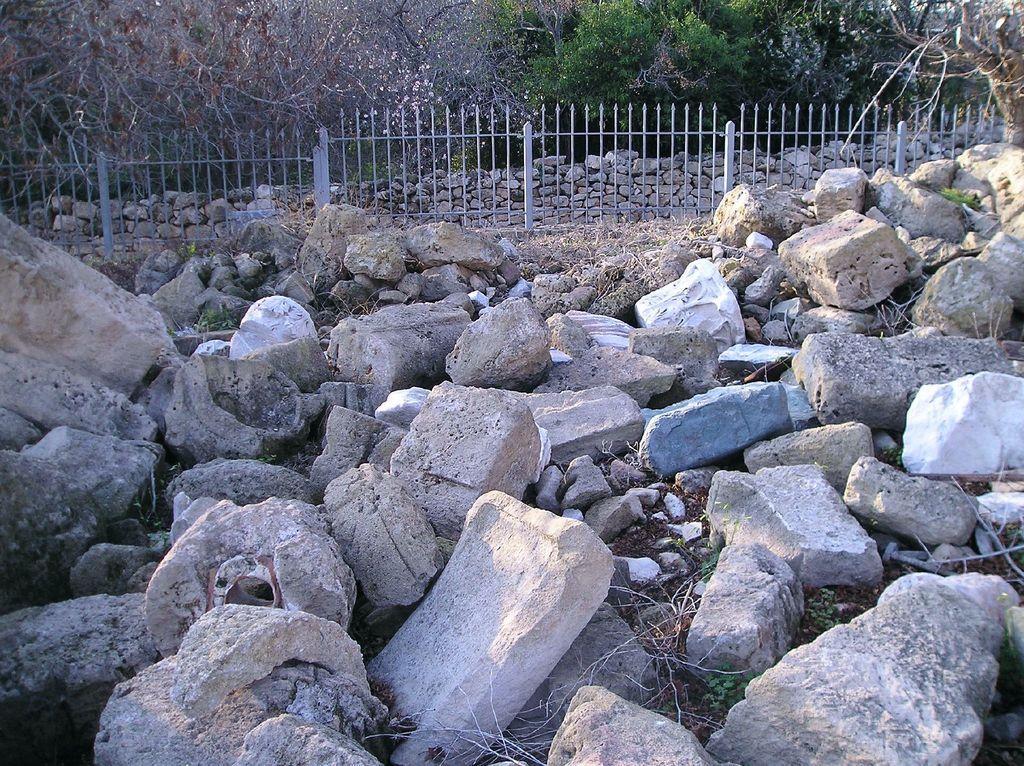In one or two sentences, can you explain what this image depicts? At the bottom of the picture, we see the stones, rocks and the grass. In the middle, we see the fence. Behind that, we see the rocks or stones. There are trees in the background. 